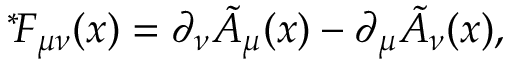<formula> <loc_0><loc_0><loc_500><loc_500>{ } ^ { * } \, F _ { \mu \nu } ( x ) = \partial _ { \nu } \tilde { A } _ { \mu } ( x ) - \partial _ { \mu } \tilde { A } _ { \nu } ( x ) ,</formula> 